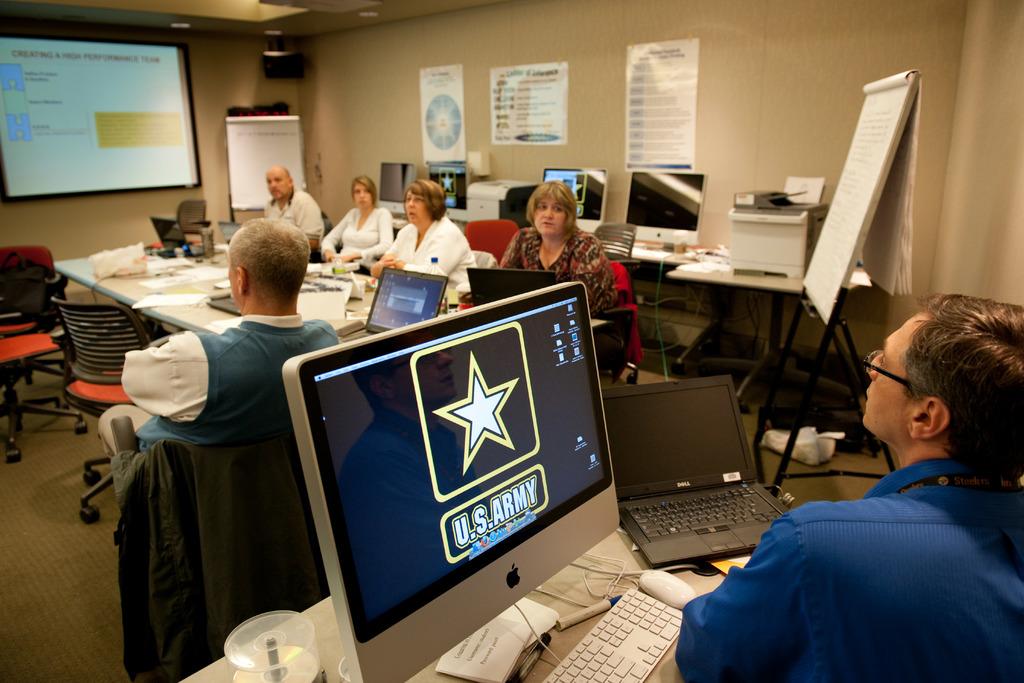What is the branch of the military displayed?
Your answer should be very brief. Army. 